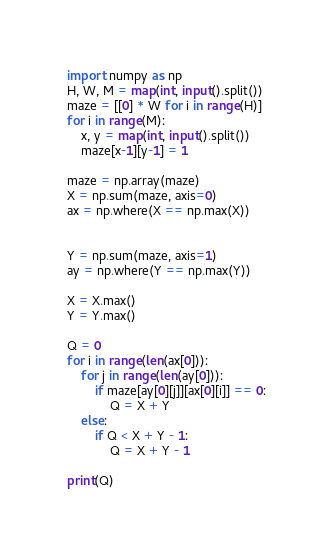Convert code to text. <code><loc_0><loc_0><loc_500><loc_500><_Python_>import numpy as np
H, W, M = map(int, input().split())
maze = [[0] * W for i in range(H)]
for i in range(M):
    x, y = map(int, input().split())
    maze[x-1][y-1] = 1

maze = np.array(maze)
X = np.sum(maze, axis=0)
ax = np.where(X == np.max(X))


Y = np.sum(maze, axis=1)
ay = np.where(Y == np.max(Y))

X = X.max()
Y = Y.max()

Q = 0
for i in range(len(ax[0])):
    for j in range(len(ay[0])):
        if maze[ay[0][j]][ax[0][i]] == 0:
            Q = X + Y
    else:
        if Q < X + Y - 1:
            Q = X + Y - 1

print(Q)</code> 